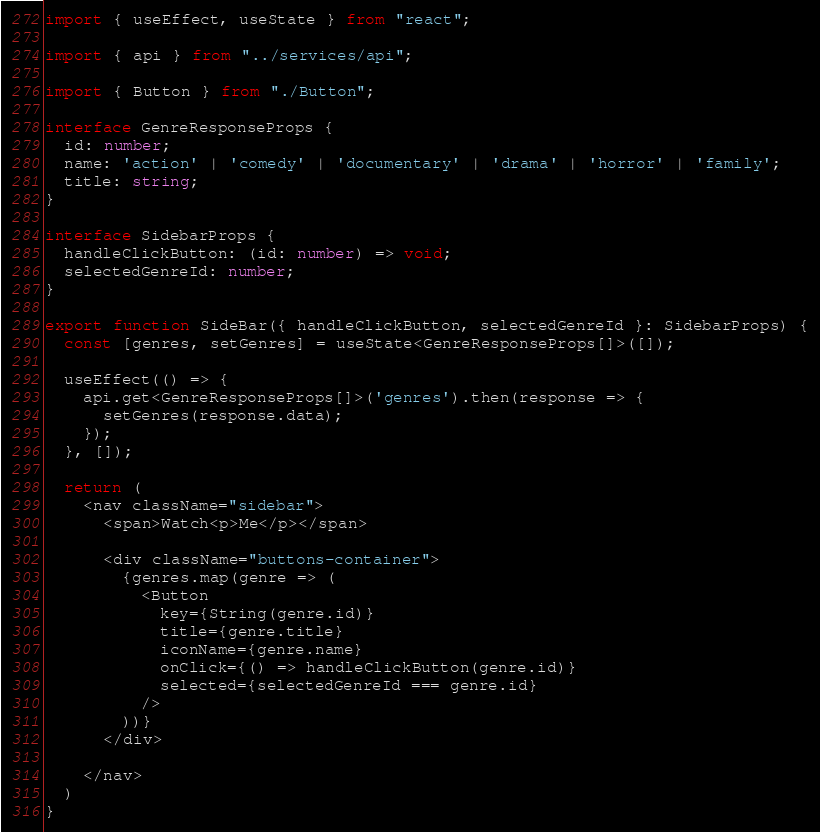<code> <loc_0><loc_0><loc_500><loc_500><_TypeScript_>import { useEffect, useState } from "react";

import { api } from "../services/api";

import { Button } from "./Button";

interface GenreResponseProps {
  id: number;
  name: 'action' | 'comedy' | 'documentary' | 'drama' | 'horror' | 'family';
  title: string;
}

interface SidebarProps {
  handleClickButton: (id: number) => void;
  selectedGenreId: number;
}

export function SideBar({ handleClickButton, selectedGenreId }: SidebarProps) {
  const [genres, setGenres] = useState<GenreResponseProps[]>([]);

  useEffect(() => {
    api.get<GenreResponseProps[]>('genres').then(response => {
      setGenres(response.data);
    });
  }, []);

  return (
    <nav className="sidebar">
      <span>Watch<p>Me</p></span>

      <div className="buttons-container">
        {genres.map(genre => (
          <Button
            key={String(genre.id)}
            title={genre.title}
            iconName={genre.name}
            onClick={() => handleClickButton(genre.id)}
            selected={selectedGenreId === genre.id}
          />
        ))}
      </div>

    </nav>
  )
}</code> 